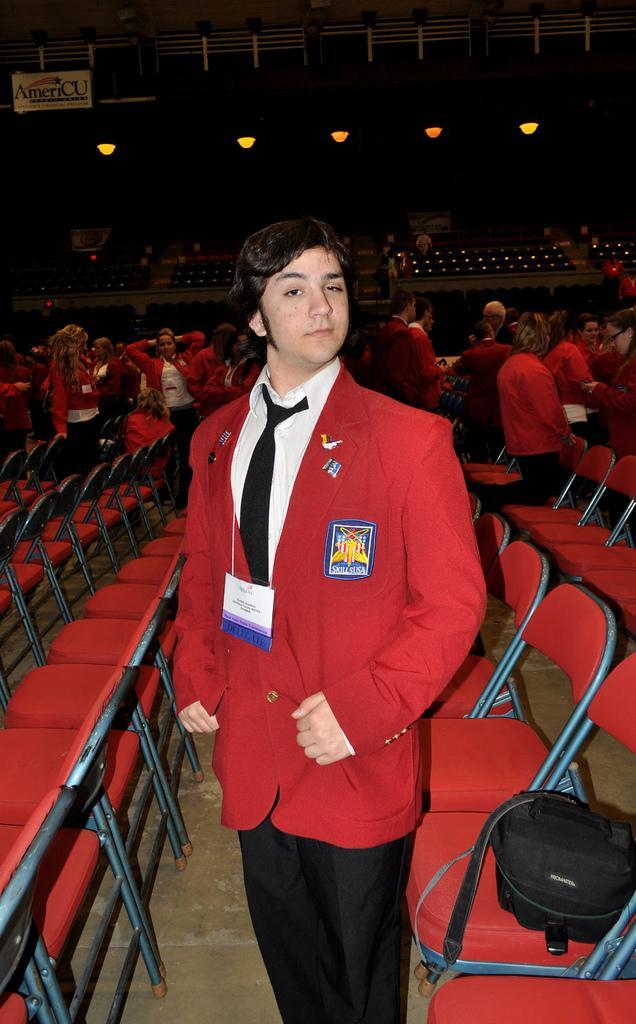In one or two sentences, can you explain what this image depicts? This picture seems to be clicked inside the hall. In the foreground we can see a person wearing a suit and standing and we can see a sling bag and the chairs and we can see the group of people seems to be standing. In the background we can see the metal rods, lights, text on the board and many other objects. 